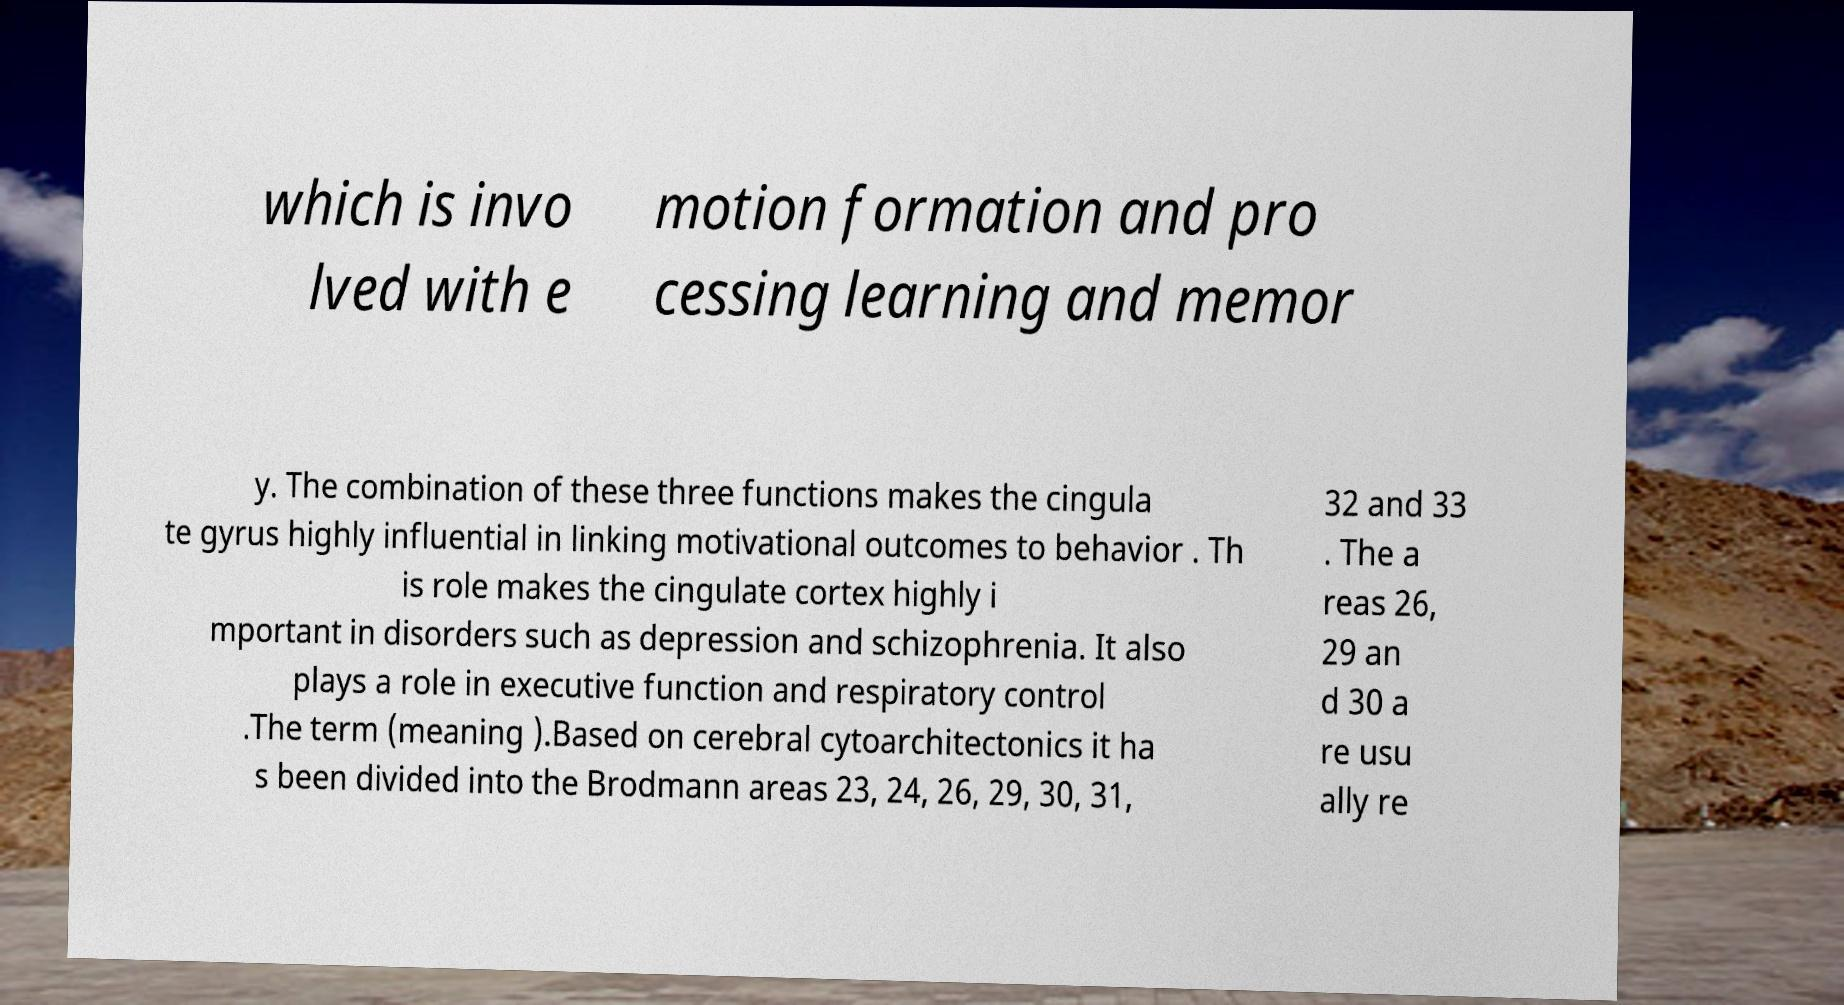Could you assist in decoding the text presented in this image and type it out clearly? which is invo lved with e motion formation and pro cessing learning and memor y. The combination of these three functions makes the cingula te gyrus highly influential in linking motivational outcomes to behavior . Th is role makes the cingulate cortex highly i mportant in disorders such as depression and schizophrenia. It also plays a role in executive function and respiratory control .The term (meaning ).Based on cerebral cytoarchitectonics it ha s been divided into the Brodmann areas 23, 24, 26, 29, 30, 31, 32 and 33 . The a reas 26, 29 an d 30 a re usu ally re 